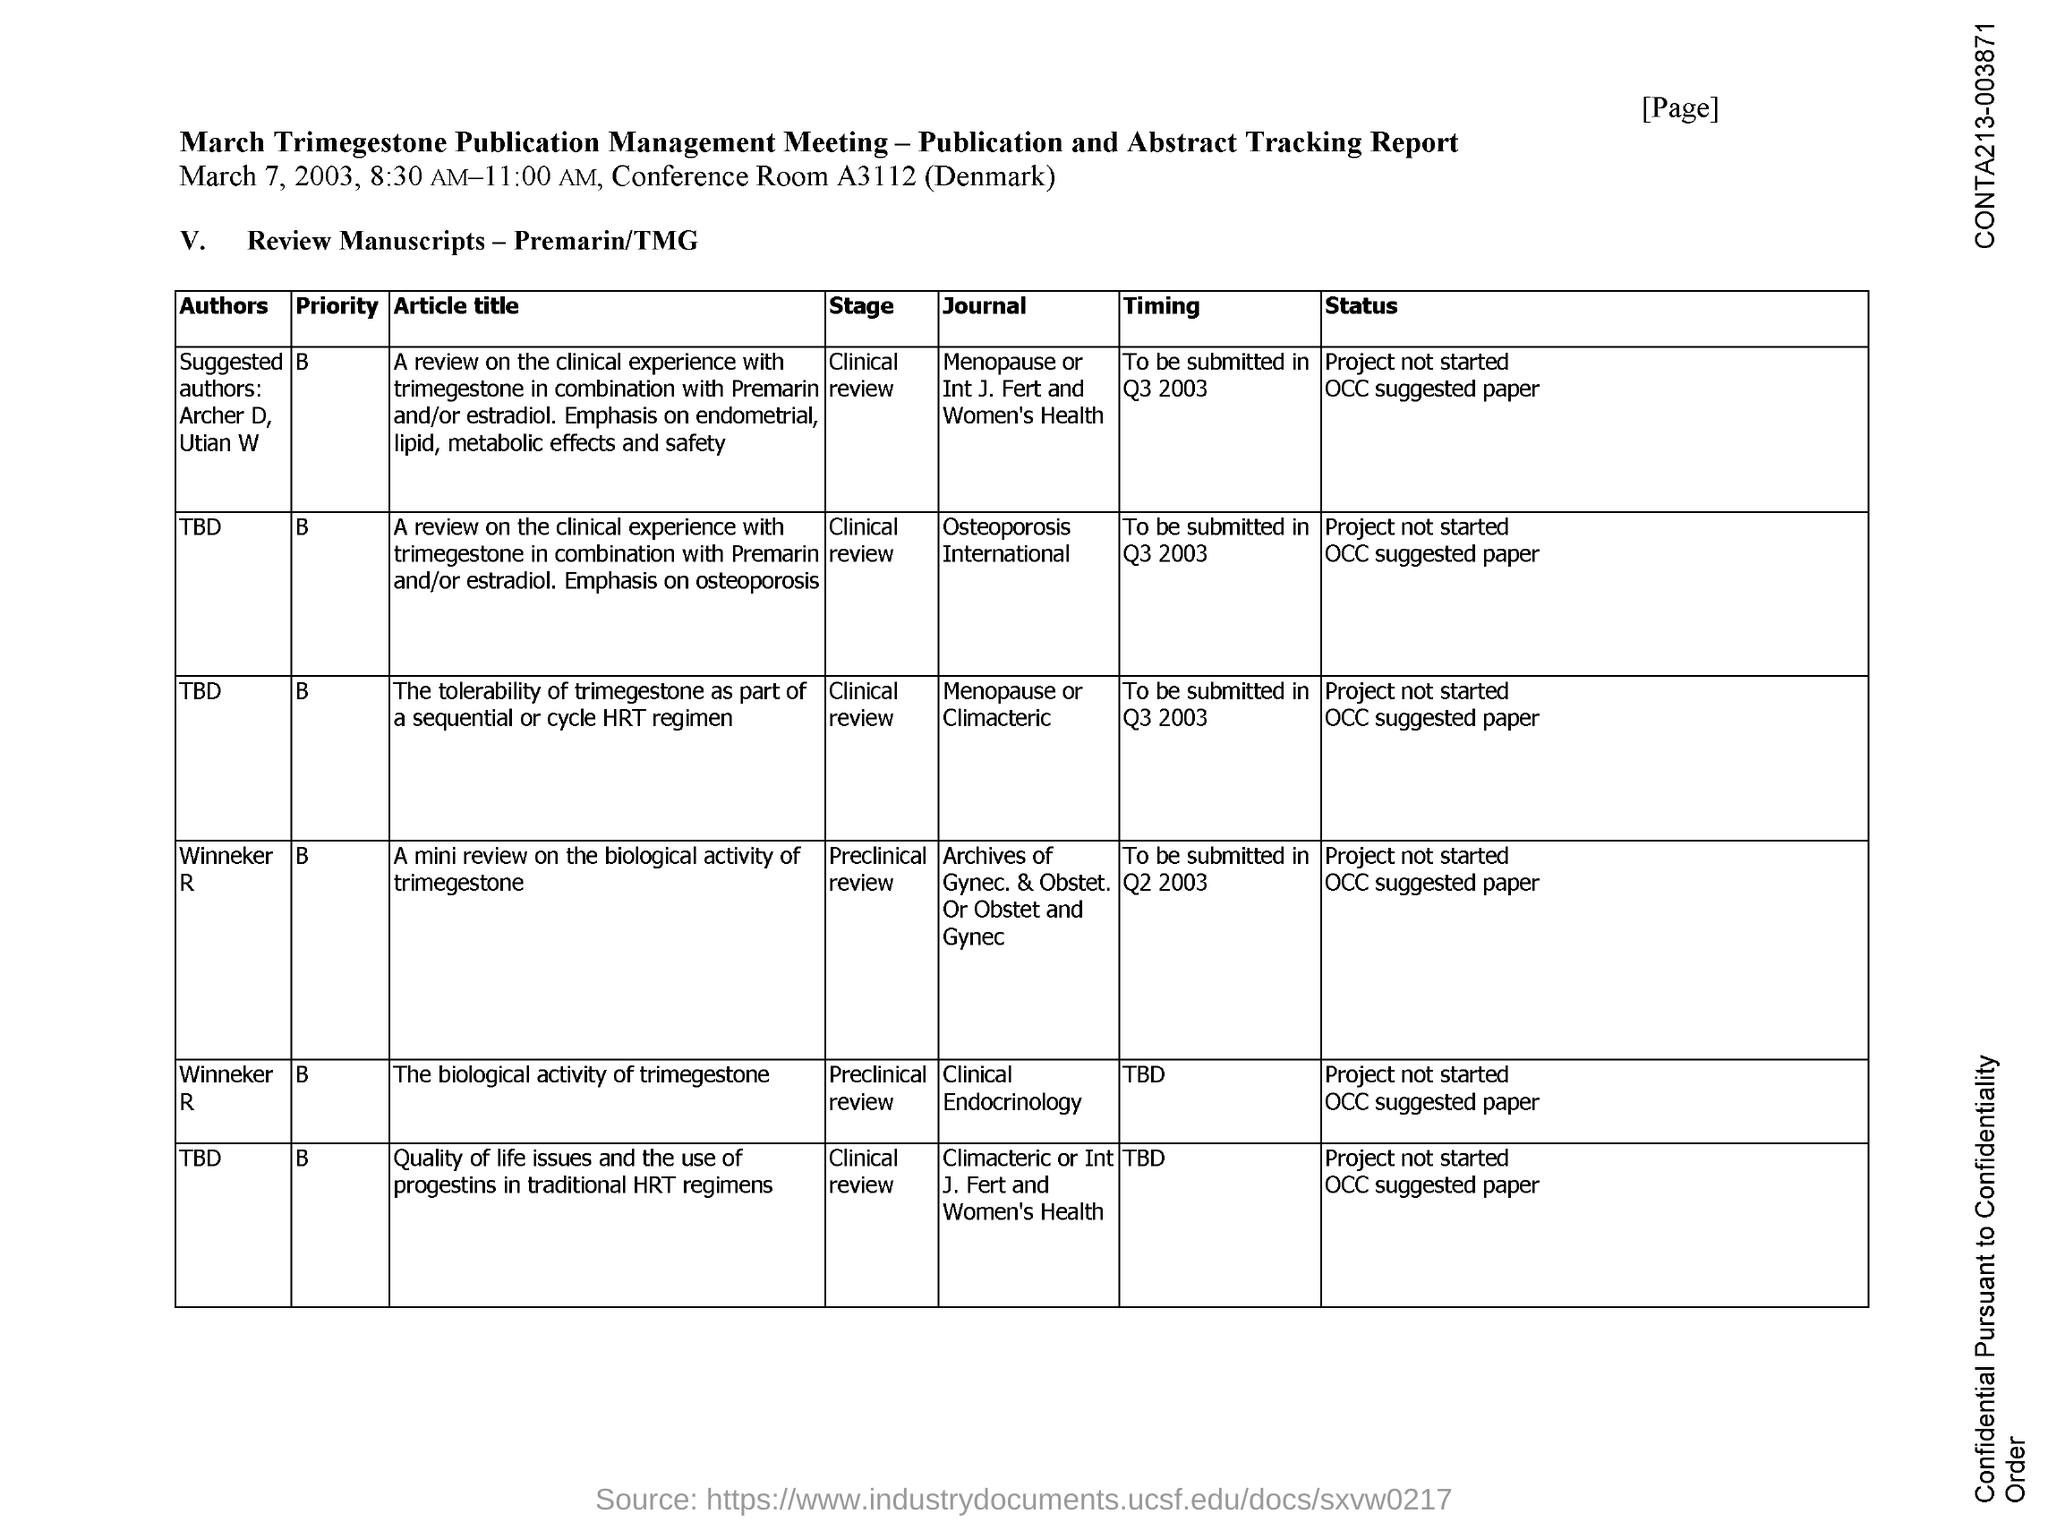Specify some key components in this picture. The conference is taking place in Denmark. The date mentioned is March 7, 2003. The conference room number is A3112. 